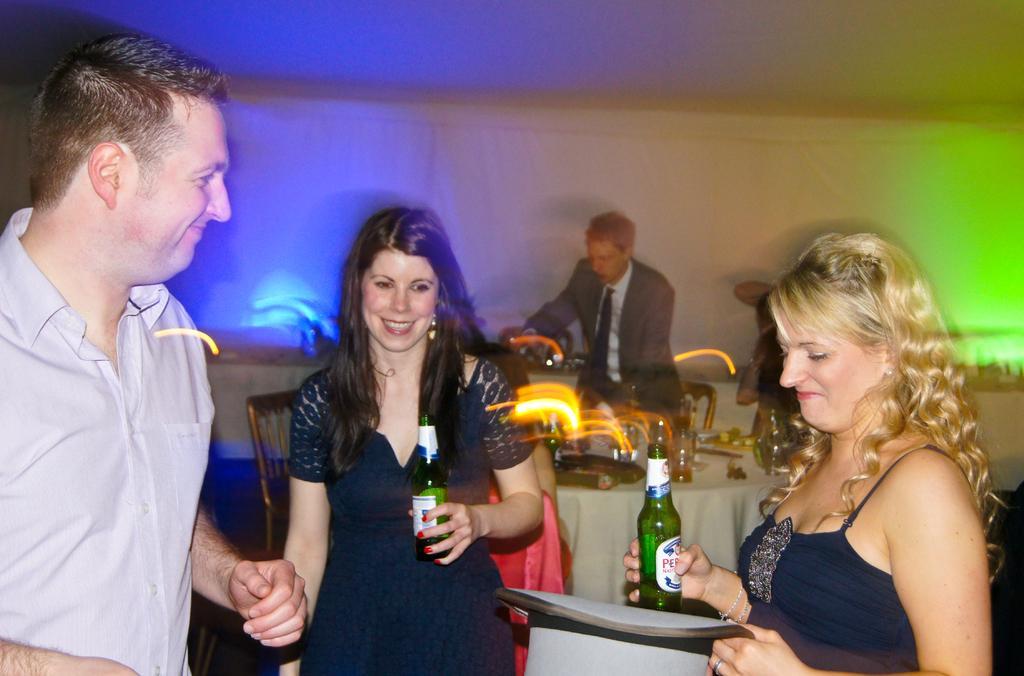Could you give a brief overview of what you see in this image? In this image, we can see a man standing, there are two women standing and they are holding wine bottles, in the background, we can see a table, on that table there are some objects and we can see a person standing. 